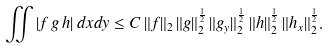Convert formula to latex. <formula><loc_0><loc_0><loc_500><loc_500>\iint | f \, g \, h | \, d x d y \leq C \, \| f \| _ { 2 } \, \| g \| _ { 2 } ^ { \frac { 1 } { 2 } } \, \| g _ { y } \| _ { 2 } ^ { \frac { 1 } { 2 } } \, \| h \| _ { 2 } ^ { \frac { 1 } { 2 } } \, \| h _ { x } \| _ { 2 } ^ { \frac { 1 } { 2 } } .</formula> 